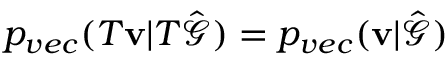Convert formula to latex. <formula><loc_0><loc_0><loc_500><loc_500>p _ { v e c } ( T v | T \hat { \mathcal { G } } ) = p _ { v e c } ( v | \hat { \mathcal { G } } )</formula> 